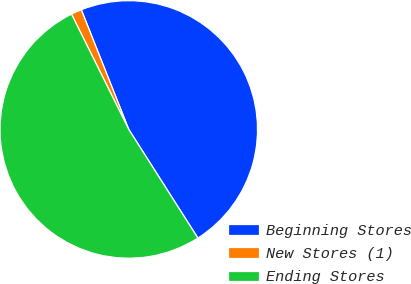Convert chart to OTSL. <chart><loc_0><loc_0><loc_500><loc_500><pie_chart><fcel>Beginning Stores<fcel>New Stores (1)<fcel>Ending Stores<nl><fcel>46.99%<fcel>1.33%<fcel>51.68%<nl></chart> 